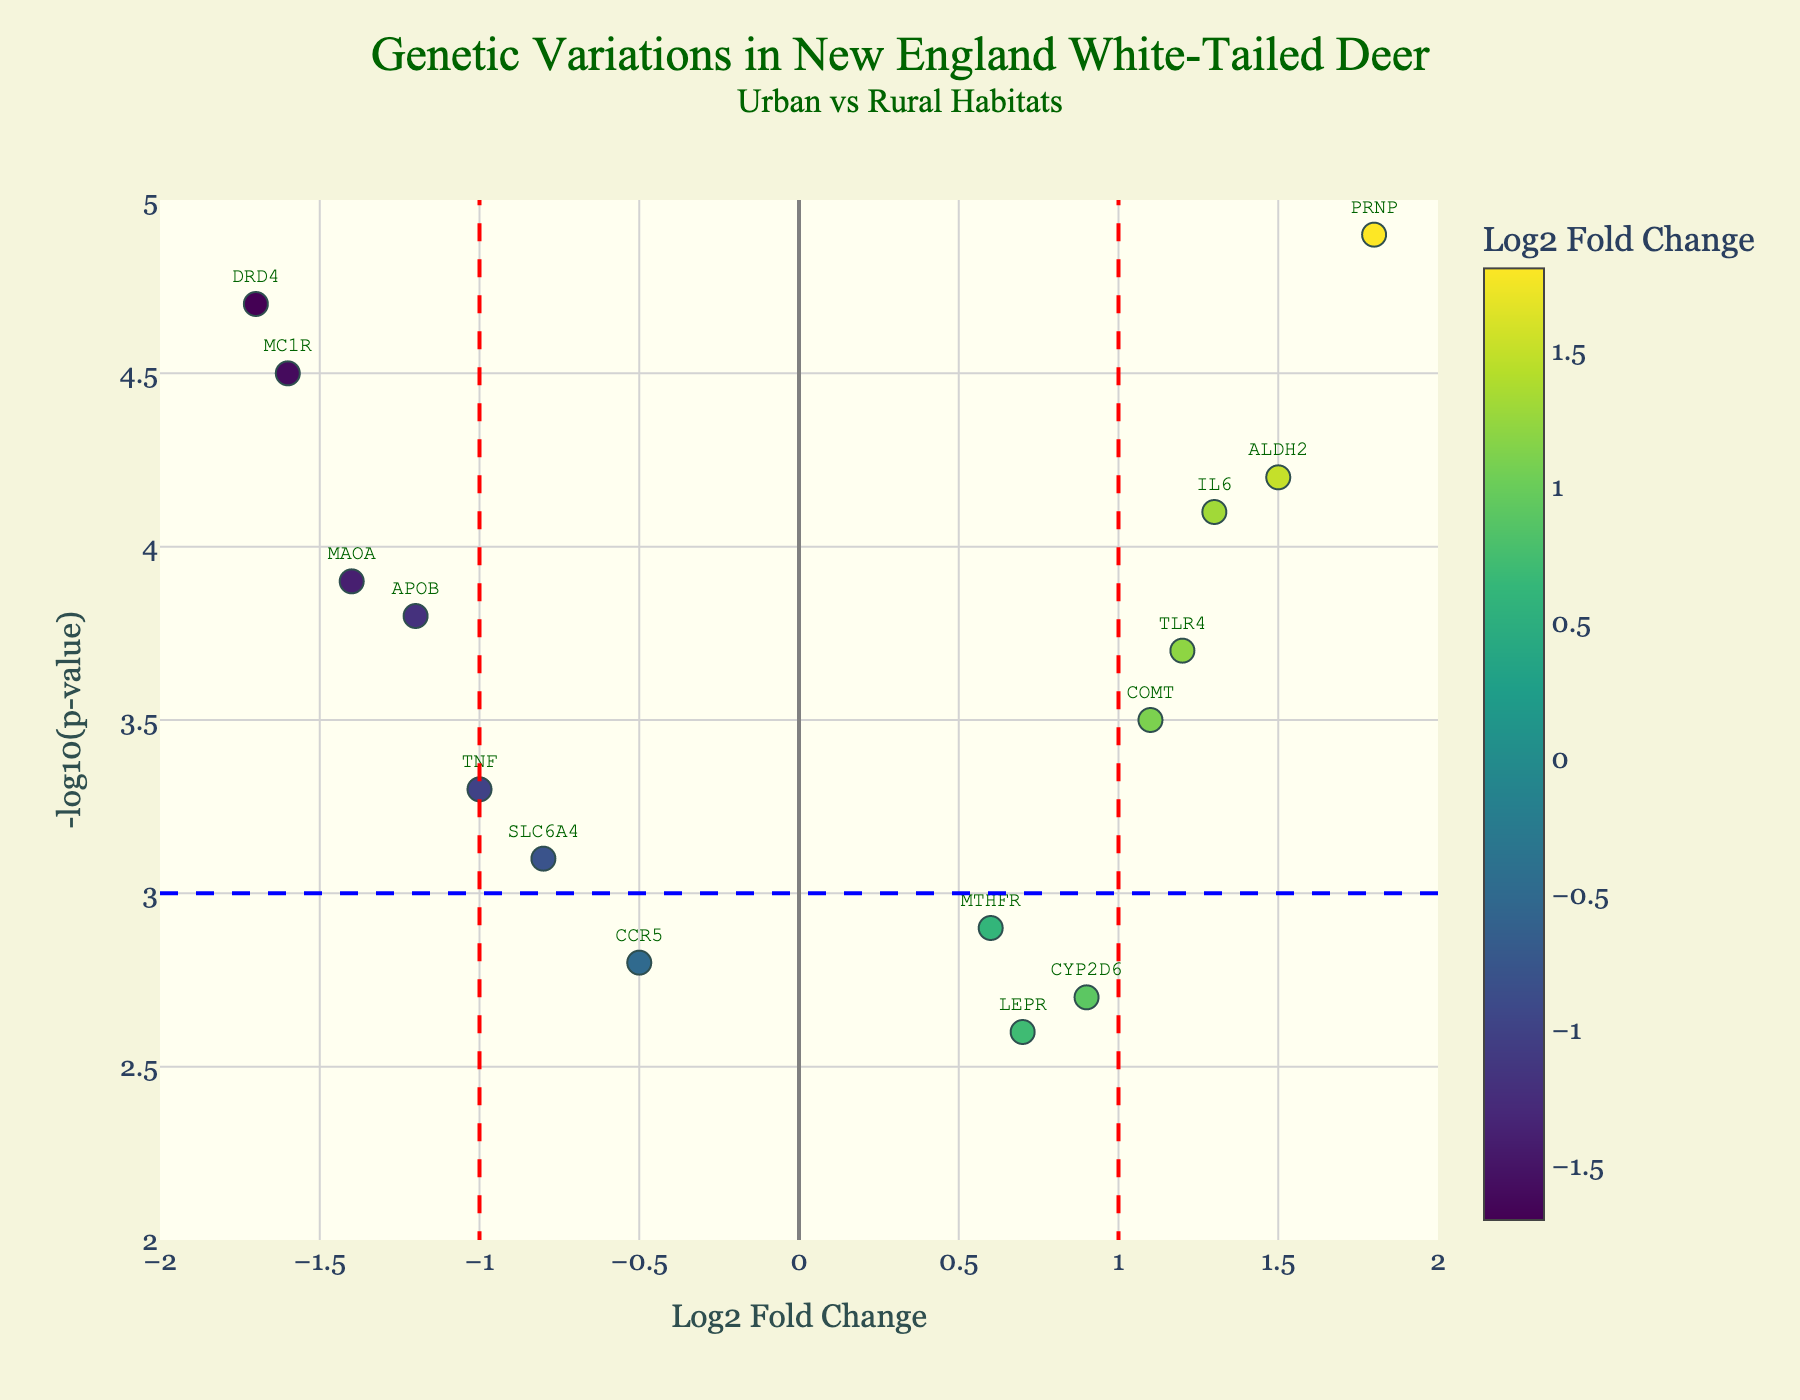What is the title of the plot? The title is usually placed at the top of the plot and describes what the plot is illustrating. In this case, the title focuses on genetic variations in white-tailed deer across urban and rural habitats.
Answer: Genetic Variations in New England White-Tailed Deer Urban vs Rural Habitats What do the horizontal and vertical dashed lines represent? The horizontal blue dashed line represents a threshold for significance in terms of -log10(p-value), and the vertical red dashed lines represent thresholds for significant Log2 Fold Change differences. These thresholds help identify which gene variations are significantly different between urban and rural habitats.
Answer: Thresholds for significance How many genes have a Log2 Fold Change greater than 1? To find this, look for points to the right of the vertical red dashed line at Log2 Fold Change = 1. The genes with Log2 Fold Changes greater than 1 are ALDH2, PRNP, IL6, TLR4, and COMT.
Answer: 5 Which gene shows the highest -log10(p-value)? Look for the highest point on the y-axis and note the gene label associated with this point. PRNP has the highest -log10(p-value) at 4.9.
Answer: PRNP Which gene shows the most significant downregulation? You need to find the gene with the lowest Log2 Fold Change and the highest -log10(p-value) among those with a Log2 Fold Change less than -1. The gene DRD4 shows the most significant downregulation with a value of -1.7 and a high -log10(p-value).
Answer: DRD4 What is the -log10(p-value) for the gene APOB? Locate the gene APOB in the plot and read the y-value. In this case, APOB has a -log10(p-value) of 3.8.
Answer: 3.8 Are more genes upregulated or downregulated with significant p-values? Compare the number of genes to the left of the Log2 Fold Change = -1 line and the number of genes to the right of the Log2 Fold Change = 1 line, both above the -log10(p-value) = 3 line. There are more genes upregulated (5 genes) than downregulated (3 genes).
Answer: Upregulated How many genes have a -log10(p-value) greater than 4? Identify the genes above the y-coordinate value of 4. There are four genes: DRD4, MAOA, ALDH2, and PRNP.
Answer: 4 